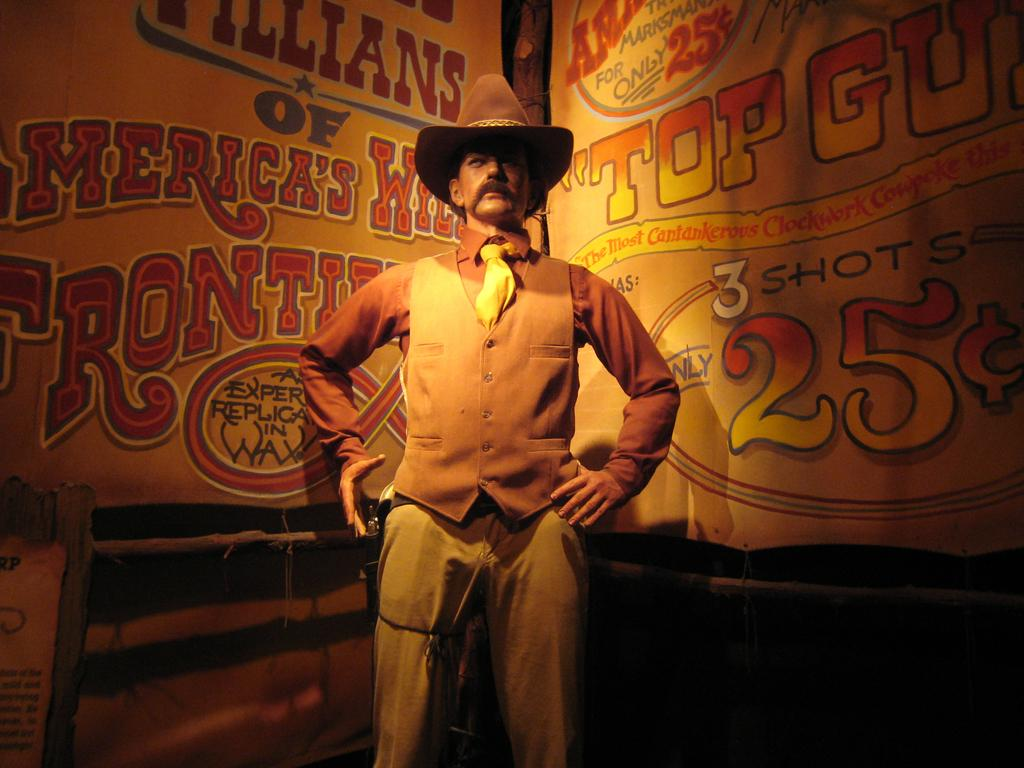What is the main subject of the image? There is a person in the image. Can you describe the person's attire? The person is wearing a hat. What is the person's posture in the image? The person is standing. What can be seen in the background of the image? There are two banners in the background of the image. What is written on the banners? The banners have writing on them. Can you tell me how many icicles are hanging from the person's hat in the image? There are no icicles present in the image, as the person is wearing a hat and not an ice-based accessory. 